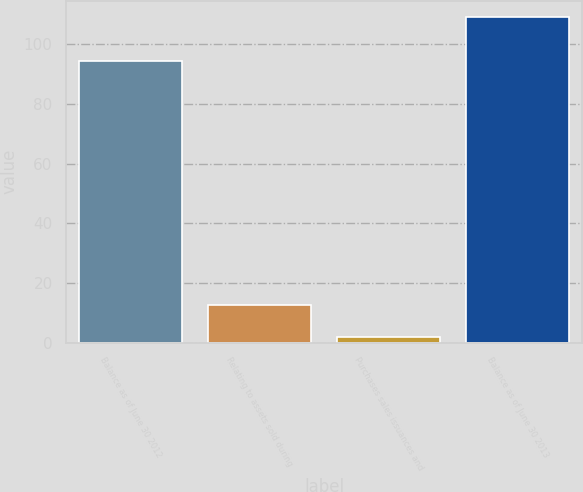<chart> <loc_0><loc_0><loc_500><loc_500><bar_chart><fcel>Balance as of June 30 2012<fcel>Relating to assets sold during<fcel>Purchases sales issuances and<fcel>Balance as of June 30 2013<nl><fcel>94.5<fcel>12.7<fcel>1.9<fcel>109.2<nl></chart> 